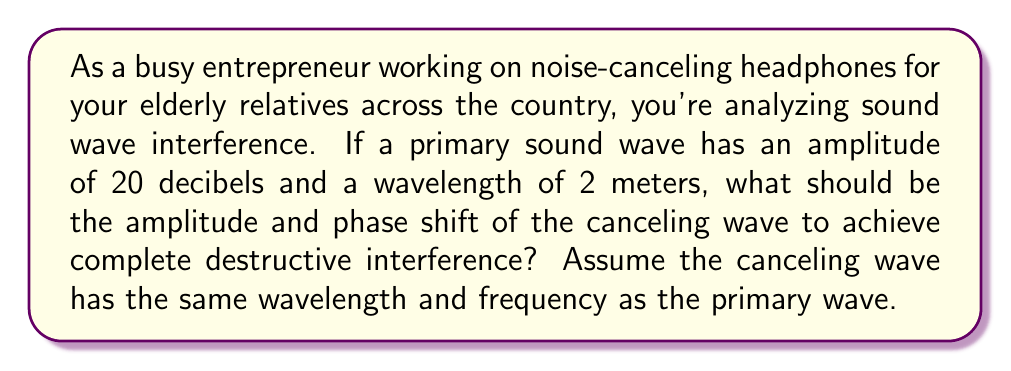Give your solution to this math problem. To solve this problem, we need to understand the principles of destructive interference in sound waves:

1. For complete destructive interference, two waves must have:
   a) Equal amplitudes
   b) Opposite phases (phase difference of π radians or 180 degrees)

2. The amplitude of the canceling wave:
   The canceling wave must have the same amplitude as the primary wave for complete cancellation.
   $$A_{canceling} = A_{primary} = 20 \text{ decibels}$$

3. The phase shift of the canceling wave:
   To be exactly out of phase with the primary wave, the canceling wave must have a phase shift of:
   $$\phi = \pi \text{ radians} = 180°$$

4. Wavelength consideration:
   Both waves have the same wavelength (2 meters), which ensures they maintain their phase relationship over distance.

5. Frequency consideration:
   The question states that both waves have the same frequency, which is crucial for maintaining the interference pattern over time.

[asy]
unitsize(1cm);

// Primary wave
pen primaryPen = blue+1;
path primaryWave = (0,0){right}..{right}(2,1)..{right}(4,0)..{right}(6,-1)..{right}(8,0);
draw(primaryWave, primaryPen);

// Canceling wave
pen cancelingPen = red+1;
path cancelingWave = (0,0){right}..{right}(2,-1)..{right}(4,0)..{right}(6,1)..{right}(8,0);
draw(cancelingWave, cancelingPen, dashed);

// Labels
label("Primary wave", (4,1.5), blue);
label("Canceling wave", (4,-1.5), red);
label("$\lambda = 2$m", (2,-2), black);
draw((0,-2)--(4,-2), arrow=Arrows(TeXHead), black);

// Amplitude
draw((0,0)--(0,1), arrow=Arrows(TeXHead), black);
label("$A = 20$ dB", (0,0.5), W, black);

// Phase shift
draw(arc((0,0), 0.5, 0, 180), arrow=Arrow, black);
label("$\phi = \pi$", (0.7,0.3), black);
[/asy]

This diagram illustrates the primary wave (solid blue) and the canceling wave (dashed red) with equal amplitudes and opposite phases, resulting in destructive interference.
Answer: The canceling wave should have an amplitude of 20 decibels and a phase shift of π radians (180 degrees) relative to the primary wave. 